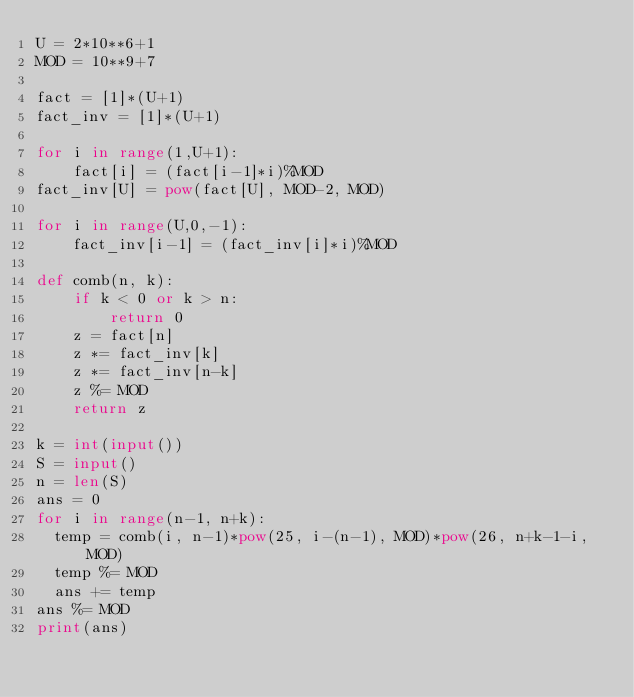Convert code to text. <code><loc_0><loc_0><loc_500><loc_500><_Python_>U = 2*10**6+1
MOD = 10**9+7
 
fact = [1]*(U+1)
fact_inv = [1]*(U+1)
 
for i in range(1,U+1):
    fact[i] = (fact[i-1]*i)%MOD
fact_inv[U] = pow(fact[U], MOD-2, MOD)
 
for i in range(U,0,-1):
    fact_inv[i-1] = (fact_inv[i]*i)%MOD

def comb(n, k):
    if k < 0 or k > n:
        return 0
    z = fact[n]
    z *= fact_inv[k]
    z *= fact_inv[n-k]
    z %= MOD
    return z

k = int(input())
S = input()
n = len(S)
ans = 0
for i in range(n-1, n+k):
  temp = comb(i, n-1)*pow(25, i-(n-1), MOD)*pow(26, n+k-1-i, MOD)
  temp %= MOD
  ans += temp
ans %= MOD
print(ans)</code> 